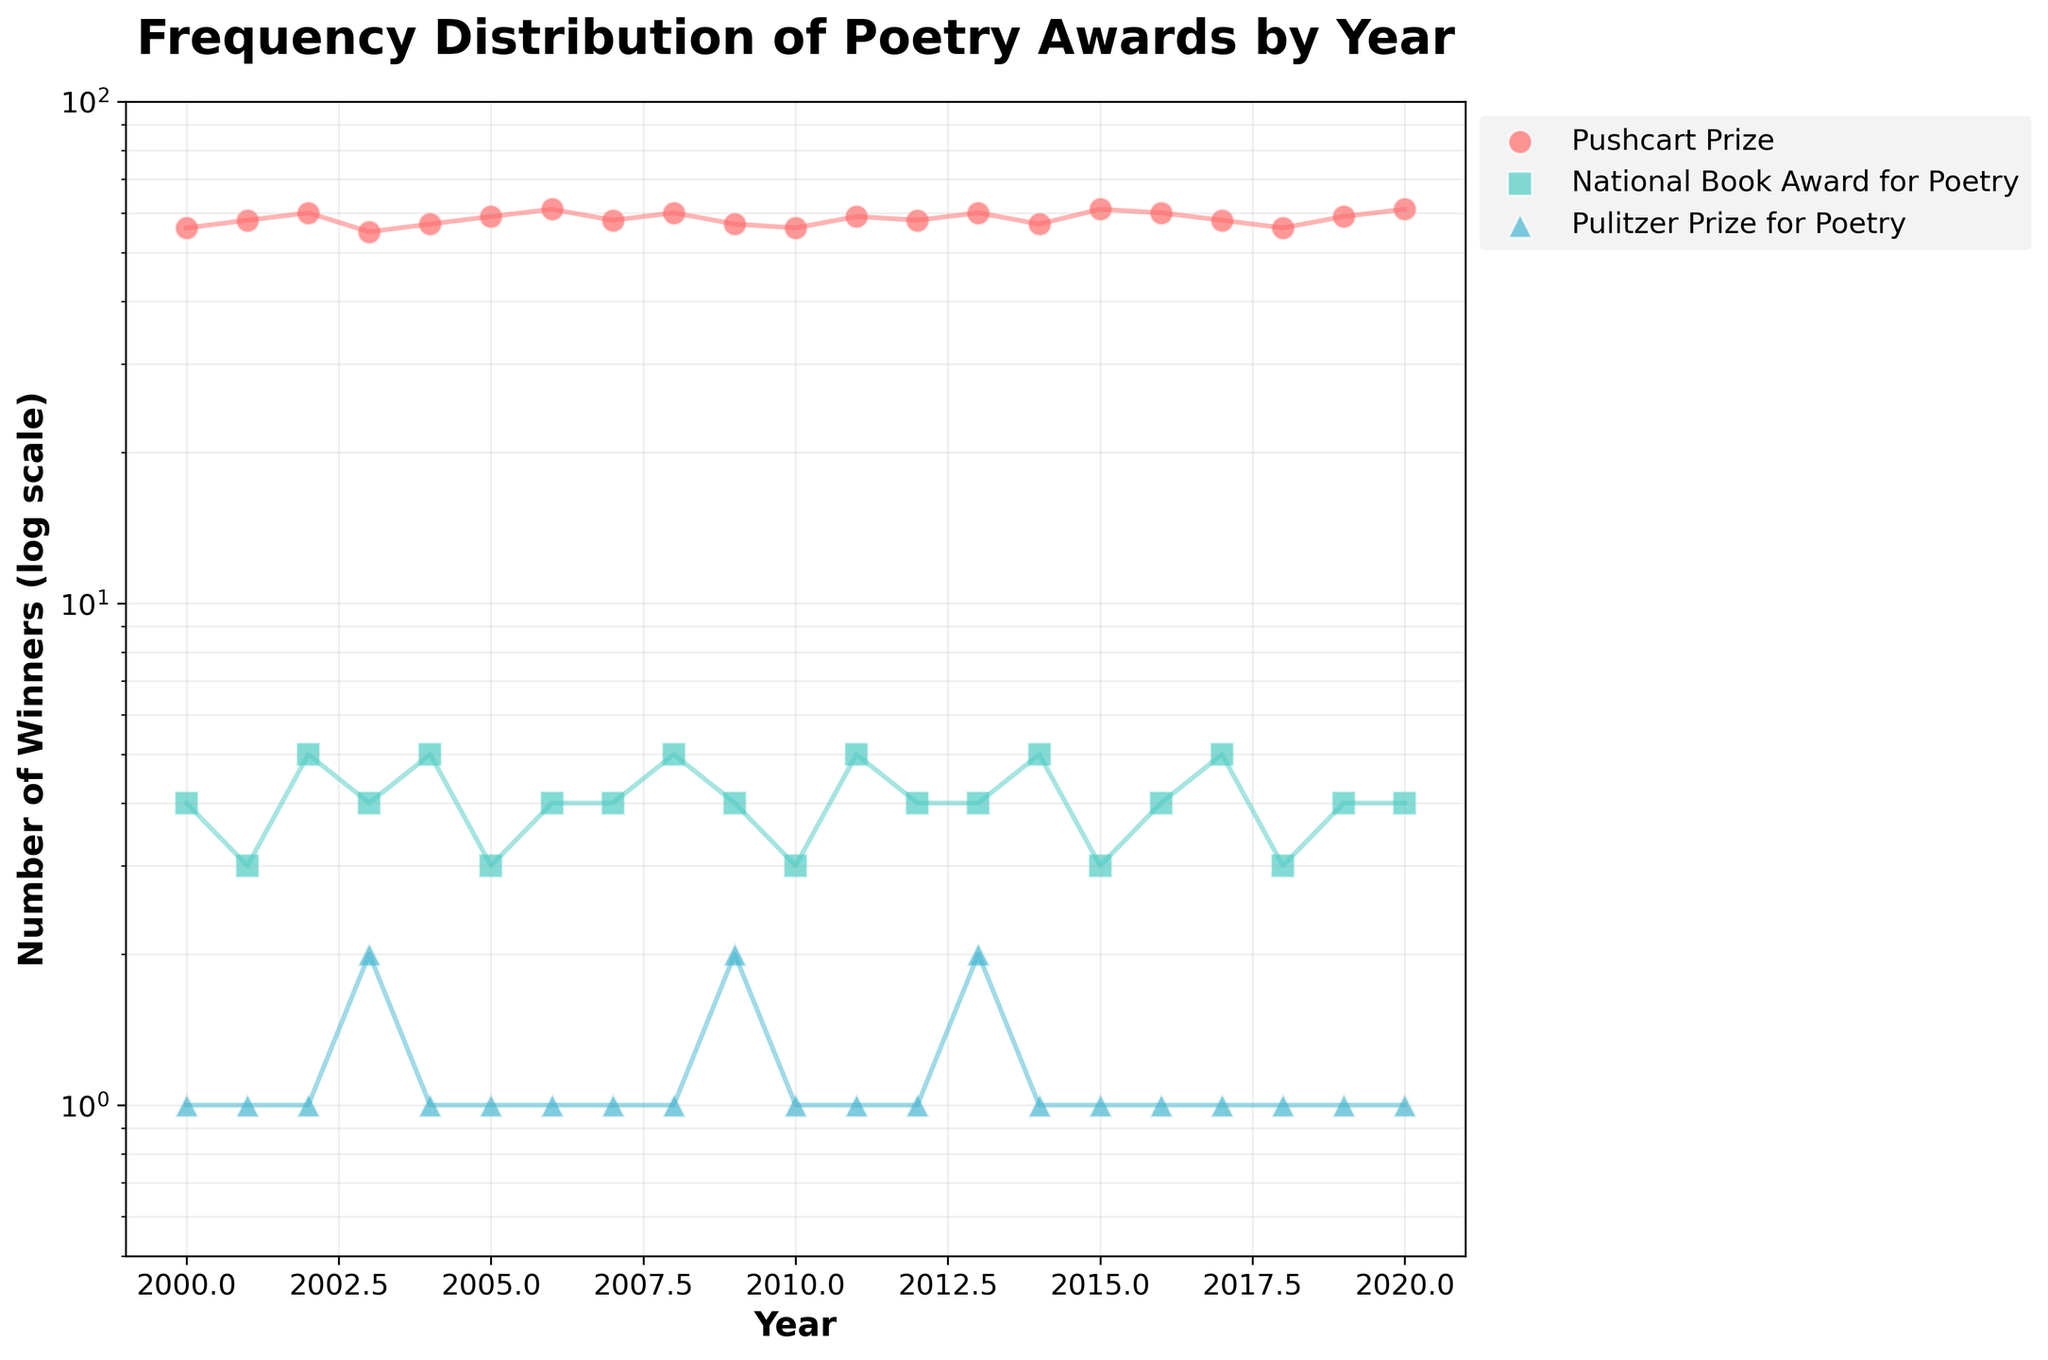What is the title of the figure? The title is typically found at the top of the figure. In this case, the title clearly states the main subject of the visualization.
Answer: Frequency Distribution of Poetry Awards by Year Which award has the most winners in each year? By looking at each year on the x-axis and identifying the highest point among the different awards on the y-axis, the Pushcart Prize has the most winners every year.
Answer: Pushcart Prize How many years does the data cover? By examining the range of years on the x-axis, the data spans from 2000 to 2020 inclusive. The difference between the start and end year plus one gives us the total number of years covered.
Answer: 21 years What range of winner counts does the log scale on the y-axis represent? The y-axis is in log scale and is labeled from just below 1 up to 100, giving a broad range representation of winners from fewer than 1 to 100.
Answer: 0.5 to 100 Which year had the most winners for the Pushcart Prize? Looking at the highest points along the Pushcart Prize data series on the plot, the year 2020 shows the highest value, which is 61 winners.
Answer: 2020 What is the general trend of winners for the Pulitzer Prize for Poetry over the years? Observing the plot's trendlines for the Pulitzer Prize for Poetry, the number of winners remains fairly constant at around 1 each year with a couple of years (2003 and 2009) where there were slight spikes to 2 winners.
Answer: Fairly constant Compare the number of winners of the National Book Award for Poetry in 2001 and 2008. By locating the points for 2001 and 2008 on the National Book Award for Poetry series line, we see that there were 3 winners in 2001 and 5 winners in 2008, with more winners in 2008.
Answer: More winners in 2008 What is the average number of winners for the Pushcart Prize in the first 5 years? Extracting data for the first 5 years (2000-2004): [56, 58, 60, 55, 57], sum these values (56 + 58 + 60 + 55 + 57 = 286), then divide by 5 to find the average: 286 / 5 = 57.2
Answer: 57.2 winners For which award and year do we see the smallest number of winners? Identify the smallest point on the plot; the Pulitzer Prize for Poetry in most years has the smallest number of winners with 1 each year.
Answer: Pulitzer Prize for Poetry in most years How many winners were there for the National Book Award for Poetry in 2015 compared to 2016? On the plot, find the values for the National Book Award for Poetry in 2015 (3 winners) and 2016 (4 winners), and compare them directly.
Answer: 2016 had more winners than 2015 